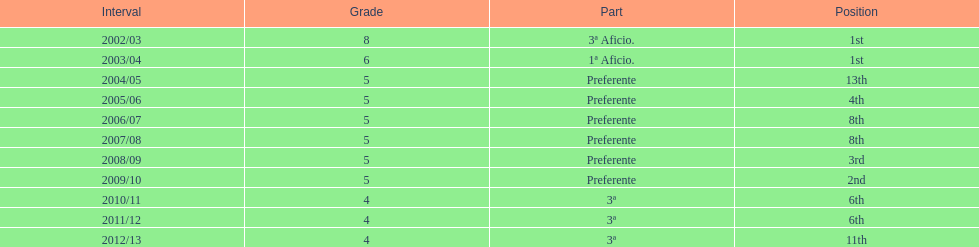How many years was the team in the 3 a division? 4. 